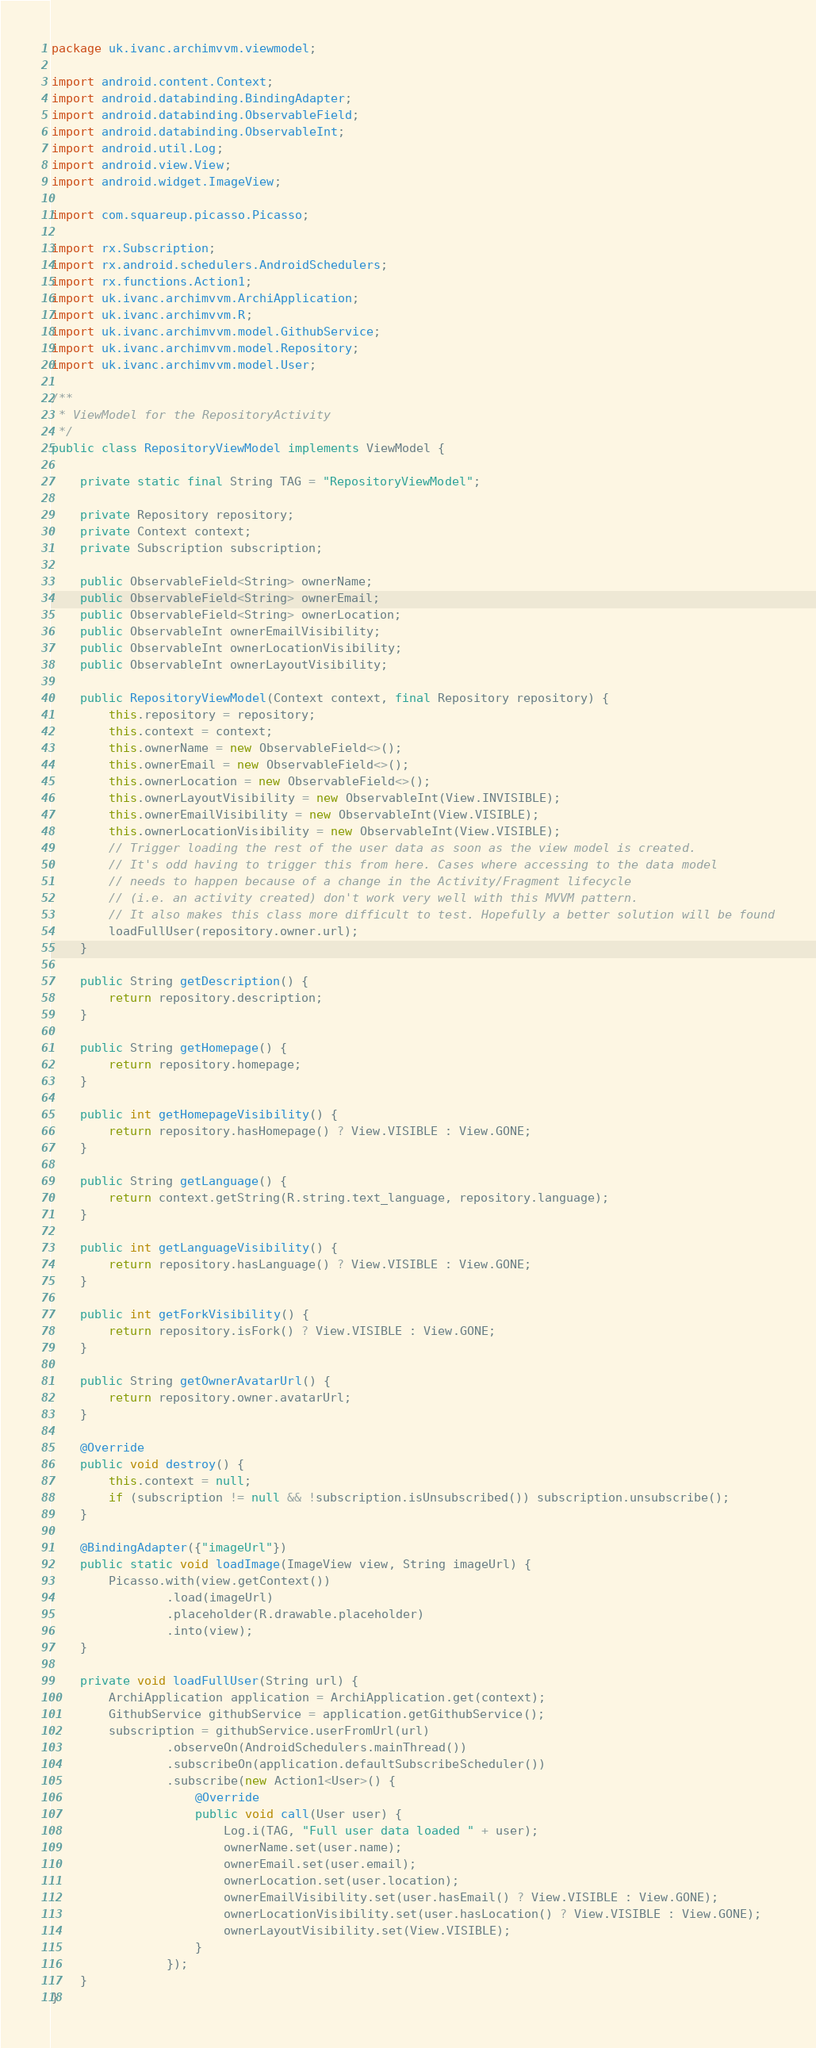<code> <loc_0><loc_0><loc_500><loc_500><_Java_>package uk.ivanc.archimvvm.viewmodel;

import android.content.Context;
import android.databinding.BindingAdapter;
import android.databinding.ObservableField;
import android.databinding.ObservableInt;
import android.util.Log;
import android.view.View;
import android.widget.ImageView;

import com.squareup.picasso.Picasso;

import rx.Subscription;
import rx.android.schedulers.AndroidSchedulers;
import rx.functions.Action1;
import uk.ivanc.archimvvm.ArchiApplication;
import uk.ivanc.archimvvm.R;
import uk.ivanc.archimvvm.model.GithubService;
import uk.ivanc.archimvvm.model.Repository;
import uk.ivanc.archimvvm.model.User;

/**
 * ViewModel for the RepositoryActivity
 */
public class RepositoryViewModel implements ViewModel {

    private static final String TAG = "RepositoryViewModel";

    private Repository repository;
    private Context context;
    private Subscription subscription;

    public ObservableField<String> ownerName;
    public ObservableField<String> ownerEmail;
    public ObservableField<String> ownerLocation;
    public ObservableInt ownerEmailVisibility;
    public ObservableInt ownerLocationVisibility;
    public ObservableInt ownerLayoutVisibility;

    public RepositoryViewModel(Context context, final Repository repository) {
        this.repository = repository;
        this.context = context;
        this.ownerName = new ObservableField<>();
        this.ownerEmail = new ObservableField<>();
        this.ownerLocation = new ObservableField<>();
        this.ownerLayoutVisibility = new ObservableInt(View.INVISIBLE);
        this.ownerEmailVisibility = new ObservableInt(View.VISIBLE);
        this.ownerLocationVisibility = new ObservableInt(View.VISIBLE);
        // Trigger loading the rest of the user data as soon as the view model is created.
        // It's odd having to trigger this from here. Cases where accessing to the data model
        // needs to happen because of a change in the Activity/Fragment lifecycle
        // (i.e. an activity created) don't work very well with this MVVM pattern.
        // It also makes this class more difficult to test. Hopefully a better solution will be found
        loadFullUser(repository.owner.url);
    }

    public String getDescription() {
        return repository.description;
    }

    public String getHomepage() {
        return repository.homepage;
    }

    public int getHomepageVisibility() {
        return repository.hasHomepage() ? View.VISIBLE : View.GONE;
    }

    public String getLanguage() {
        return context.getString(R.string.text_language, repository.language);
    }

    public int getLanguageVisibility() {
        return repository.hasLanguage() ? View.VISIBLE : View.GONE;
    }

    public int getForkVisibility() {
        return repository.isFork() ? View.VISIBLE : View.GONE;
    }

    public String getOwnerAvatarUrl() {
        return repository.owner.avatarUrl;
    }

    @Override
    public void destroy() {
        this.context = null;
        if (subscription != null && !subscription.isUnsubscribed()) subscription.unsubscribe();
    }

    @BindingAdapter({"imageUrl"})
    public static void loadImage(ImageView view, String imageUrl) {
        Picasso.with(view.getContext())
                .load(imageUrl)
                .placeholder(R.drawable.placeholder)
                .into(view);
    }

    private void loadFullUser(String url) {
        ArchiApplication application = ArchiApplication.get(context);
        GithubService githubService = application.getGithubService();
        subscription = githubService.userFromUrl(url)
                .observeOn(AndroidSchedulers.mainThread())
                .subscribeOn(application.defaultSubscribeScheduler())
                .subscribe(new Action1<User>() {
                    @Override
                    public void call(User user) {
                        Log.i(TAG, "Full user data loaded " + user);
                        ownerName.set(user.name);
                        ownerEmail.set(user.email);
                        ownerLocation.set(user.location);
                        ownerEmailVisibility.set(user.hasEmail() ? View.VISIBLE : View.GONE);
                        ownerLocationVisibility.set(user.hasLocation() ? View.VISIBLE : View.GONE);
                        ownerLayoutVisibility.set(View.VISIBLE);
                    }
                });
    }
}
</code> 